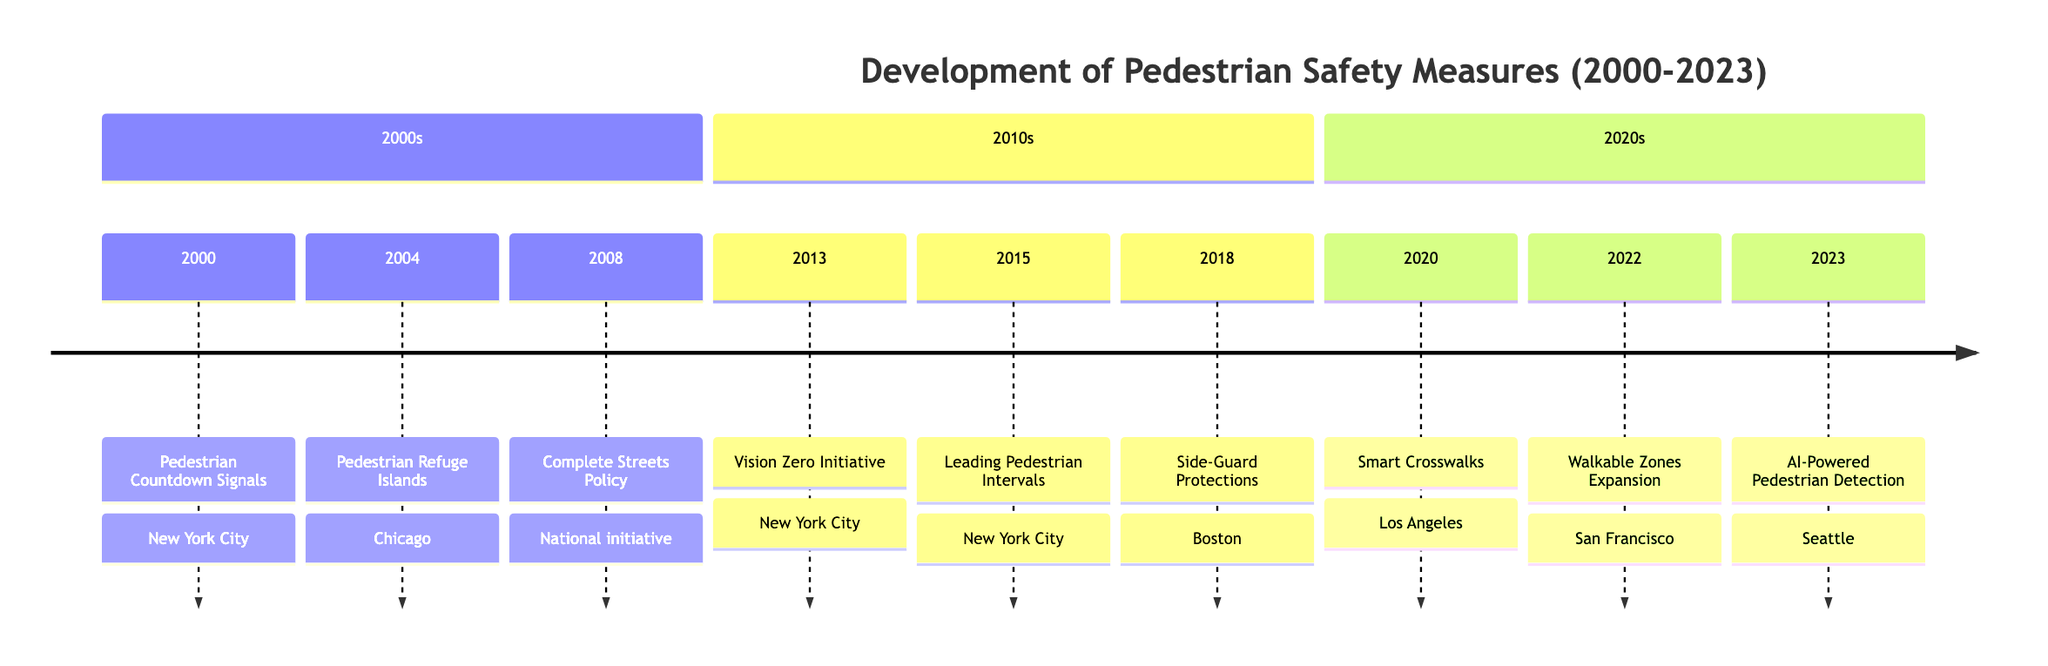What event occurred in the year 2008? The diagram shows that in 2008, the launch of the Complete Streets Policy took place, which was a national initiative advocated by the National Complete Streets Coalition.
Answer: Complete Streets Policy How many events are listed in the timeline? By counting the individual events shown in the timeline, we can see there are a total of 9 events from 2000 to 2023.
Answer: 9 What city implemented Leading Pedestrian Intervals in 2015? Referring to the timeline, it indicates that New York City was the location where Leading Pedestrian Intervals were implemented in 2015.
Answer: New York City Which safety measure was introduced in 2020? Looking at the events listed for the year 2020, the timeline specifies that smart crosswalks were deployed in Los Angeles.
Answer: Smart Crosswalks What common theme is observed in the events between 2013 and 2023? Analyzing events from 2013 to 2023, it is noted that all events are focused on improving pedestrian safety measures in urban areas.
Answer: Pedestrian Safety Which two cities saw the implementation of pedestrian safety measures in the 2010s? The timeline indicates that during the 2010s, New York City and Boston both implemented pedestrian safety measures, specifically Vision Zero and Side-Guard Protections respectively.
Answer: New York City, Boston What year saw the implementation of pedestrian refuge islands? Checking the timeline details, pedestrian refuge islands were introduced in Chicago in the year 2004.
Answer: 2004 What was the key focus of the Vision Zero Initiative? The timeline explicitly states that the Vision Zero Initiative aimed at eliminating all traffic fatalities with a significant focus on pedestrian safety measures.
Answer: Eliminate traffic fatalities What does the introduction of AI-Powered Pedestrian Detection Systems represent in 2023? The timeline indicates that this adoption represents an advancement in technology for optimizing pedestrian crossing times and enhancing safety in urban areas.
Answer: Advancing technology for pedestrian safety 